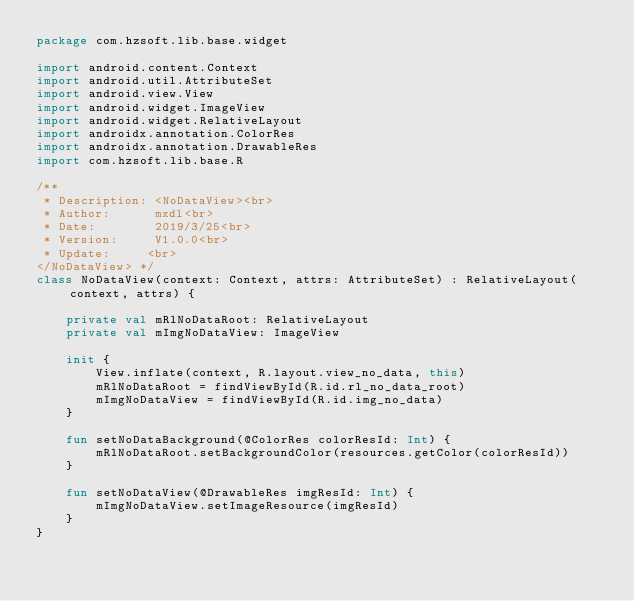<code> <loc_0><loc_0><loc_500><loc_500><_Kotlin_>package com.hzsoft.lib.base.widget

import android.content.Context
import android.util.AttributeSet
import android.view.View
import android.widget.ImageView
import android.widget.RelativeLayout
import androidx.annotation.ColorRes
import androidx.annotation.DrawableRes
import com.hzsoft.lib.base.R

/**
 * Description: <NoDataView><br>
 * Author:      mxdl<br>
 * Date:        2019/3/25<br>
 * Version:     V1.0.0<br>
 * Update:     <br>
</NoDataView> */
class NoDataView(context: Context, attrs: AttributeSet) : RelativeLayout(context, attrs) {

    private val mRlNoDataRoot: RelativeLayout
    private val mImgNoDataView: ImageView

    init {
        View.inflate(context, R.layout.view_no_data, this)
        mRlNoDataRoot = findViewById(R.id.rl_no_data_root)
        mImgNoDataView = findViewById(R.id.img_no_data)
    }

    fun setNoDataBackground(@ColorRes colorResId: Int) {
        mRlNoDataRoot.setBackgroundColor(resources.getColor(colorResId))
    }

    fun setNoDataView(@DrawableRes imgResId: Int) {
        mImgNoDataView.setImageResource(imgResId)
    }
}
</code> 